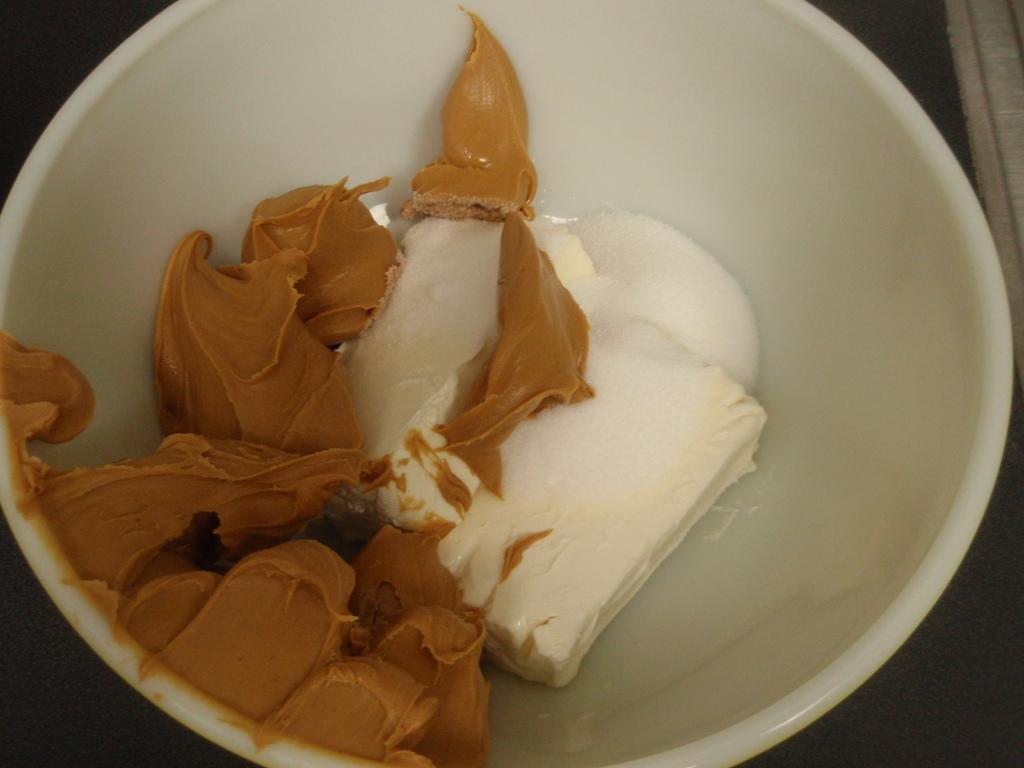What is in the bowl that is visible in the image? There is a bowl in the image, and it contains chocolate and some other cream. Can you describe the contents of the bowl in more detail? The bowl contains chocolate and another type of cream, but the specific type of cream is not mentioned in the facts. What is the primary color of the contents in the bowl? The primary color of the contents in the bowl is likely to be brown, as chocolate is typically brown. What decision was made by the crow in the image? There is no crow present in the image, so no decision can be attributed to a crow. 